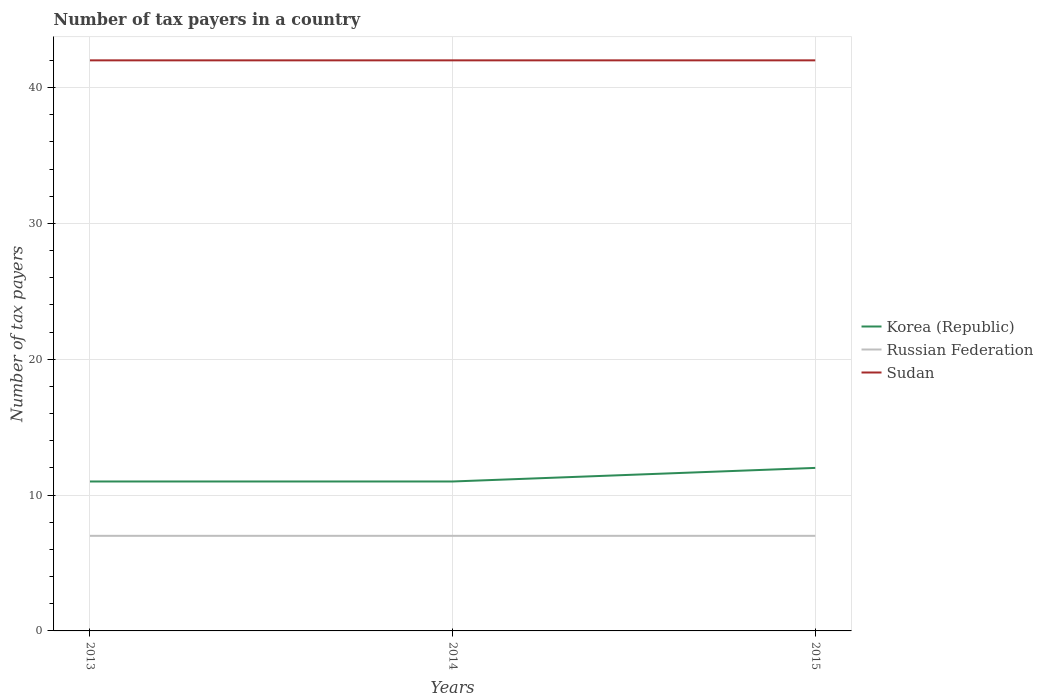Is the number of lines equal to the number of legend labels?
Your answer should be very brief. Yes. Across all years, what is the maximum number of tax payers in in Sudan?
Offer a very short reply. 42. What is the total number of tax payers in in Russian Federation in the graph?
Provide a short and direct response. 0. Is the number of tax payers in in Russian Federation strictly greater than the number of tax payers in in Korea (Republic) over the years?
Make the answer very short. Yes. How many years are there in the graph?
Make the answer very short. 3. What is the difference between two consecutive major ticks on the Y-axis?
Offer a terse response. 10. Are the values on the major ticks of Y-axis written in scientific E-notation?
Your answer should be very brief. No. Does the graph contain any zero values?
Offer a very short reply. No. How many legend labels are there?
Provide a short and direct response. 3. What is the title of the graph?
Keep it short and to the point. Number of tax payers in a country. What is the label or title of the Y-axis?
Provide a succinct answer. Number of tax payers. What is the Number of tax payers of Korea (Republic) in 2013?
Your response must be concise. 11. What is the Number of tax payers in Korea (Republic) in 2014?
Give a very brief answer. 11. What is the Number of tax payers in Korea (Republic) in 2015?
Ensure brevity in your answer.  12. What is the Number of tax payers of Sudan in 2015?
Your answer should be very brief. 42. Across all years, what is the minimum Number of tax payers in Korea (Republic)?
Provide a succinct answer. 11. Across all years, what is the minimum Number of tax payers in Sudan?
Keep it short and to the point. 42. What is the total Number of tax payers of Korea (Republic) in the graph?
Make the answer very short. 34. What is the total Number of tax payers of Sudan in the graph?
Your response must be concise. 126. What is the difference between the Number of tax payers in Sudan in 2013 and that in 2014?
Your answer should be compact. 0. What is the difference between the Number of tax payers in Korea (Republic) in 2013 and that in 2015?
Give a very brief answer. -1. What is the difference between the Number of tax payers of Sudan in 2013 and that in 2015?
Make the answer very short. 0. What is the difference between the Number of tax payers in Korea (Republic) in 2014 and that in 2015?
Give a very brief answer. -1. What is the difference between the Number of tax payers in Korea (Republic) in 2013 and the Number of tax payers in Sudan in 2014?
Offer a terse response. -31. What is the difference between the Number of tax payers in Russian Federation in 2013 and the Number of tax payers in Sudan in 2014?
Give a very brief answer. -35. What is the difference between the Number of tax payers in Korea (Republic) in 2013 and the Number of tax payers in Sudan in 2015?
Offer a terse response. -31. What is the difference between the Number of tax payers of Russian Federation in 2013 and the Number of tax payers of Sudan in 2015?
Offer a terse response. -35. What is the difference between the Number of tax payers of Korea (Republic) in 2014 and the Number of tax payers of Sudan in 2015?
Ensure brevity in your answer.  -31. What is the difference between the Number of tax payers in Russian Federation in 2014 and the Number of tax payers in Sudan in 2015?
Give a very brief answer. -35. What is the average Number of tax payers of Korea (Republic) per year?
Your response must be concise. 11.33. In the year 2013, what is the difference between the Number of tax payers in Korea (Republic) and Number of tax payers in Russian Federation?
Your answer should be compact. 4. In the year 2013, what is the difference between the Number of tax payers of Korea (Republic) and Number of tax payers of Sudan?
Keep it short and to the point. -31. In the year 2013, what is the difference between the Number of tax payers of Russian Federation and Number of tax payers of Sudan?
Offer a terse response. -35. In the year 2014, what is the difference between the Number of tax payers of Korea (Republic) and Number of tax payers of Sudan?
Provide a succinct answer. -31. In the year 2014, what is the difference between the Number of tax payers of Russian Federation and Number of tax payers of Sudan?
Give a very brief answer. -35. In the year 2015, what is the difference between the Number of tax payers in Korea (Republic) and Number of tax payers in Russian Federation?
Provide a succinct answer. 5. In the year 2015, what is the difference between the Number of tax payers in Korea (Republic) and Number of tax payers in Sudan?
Ensure brevity in your answer.  -30. In the year 2015, what is the difference between the Number of tax payers in Russian Federation and Number of tax payers in Sudan?
Offer a terse response. -35. What is the ratio of the Number of tax payers of Sudan in 2013 to that in 2014?
Give a very brief answer. 1. What is the ratio of the Number of tax payers in Russian Federation in 2013 to that in 2015?
Give a very brief answer. 1. What is the ratio of the Number of tax payers in Korea (Republic) in 2014 to that in 2015?
Offer a very short reply. 0.92. What is the ratio of the Number of tax payers of Russian Federation in 2014 to that in 2015?
Your answer should be very brief. 1. What is the difference between the highest and the second highest Number of tax payers of Sudan?
Provide a succinct answer. 0. What is the difference between the highest and the lowest Number of tax payers in Sudan?
Keep it short and to the point. 0. 